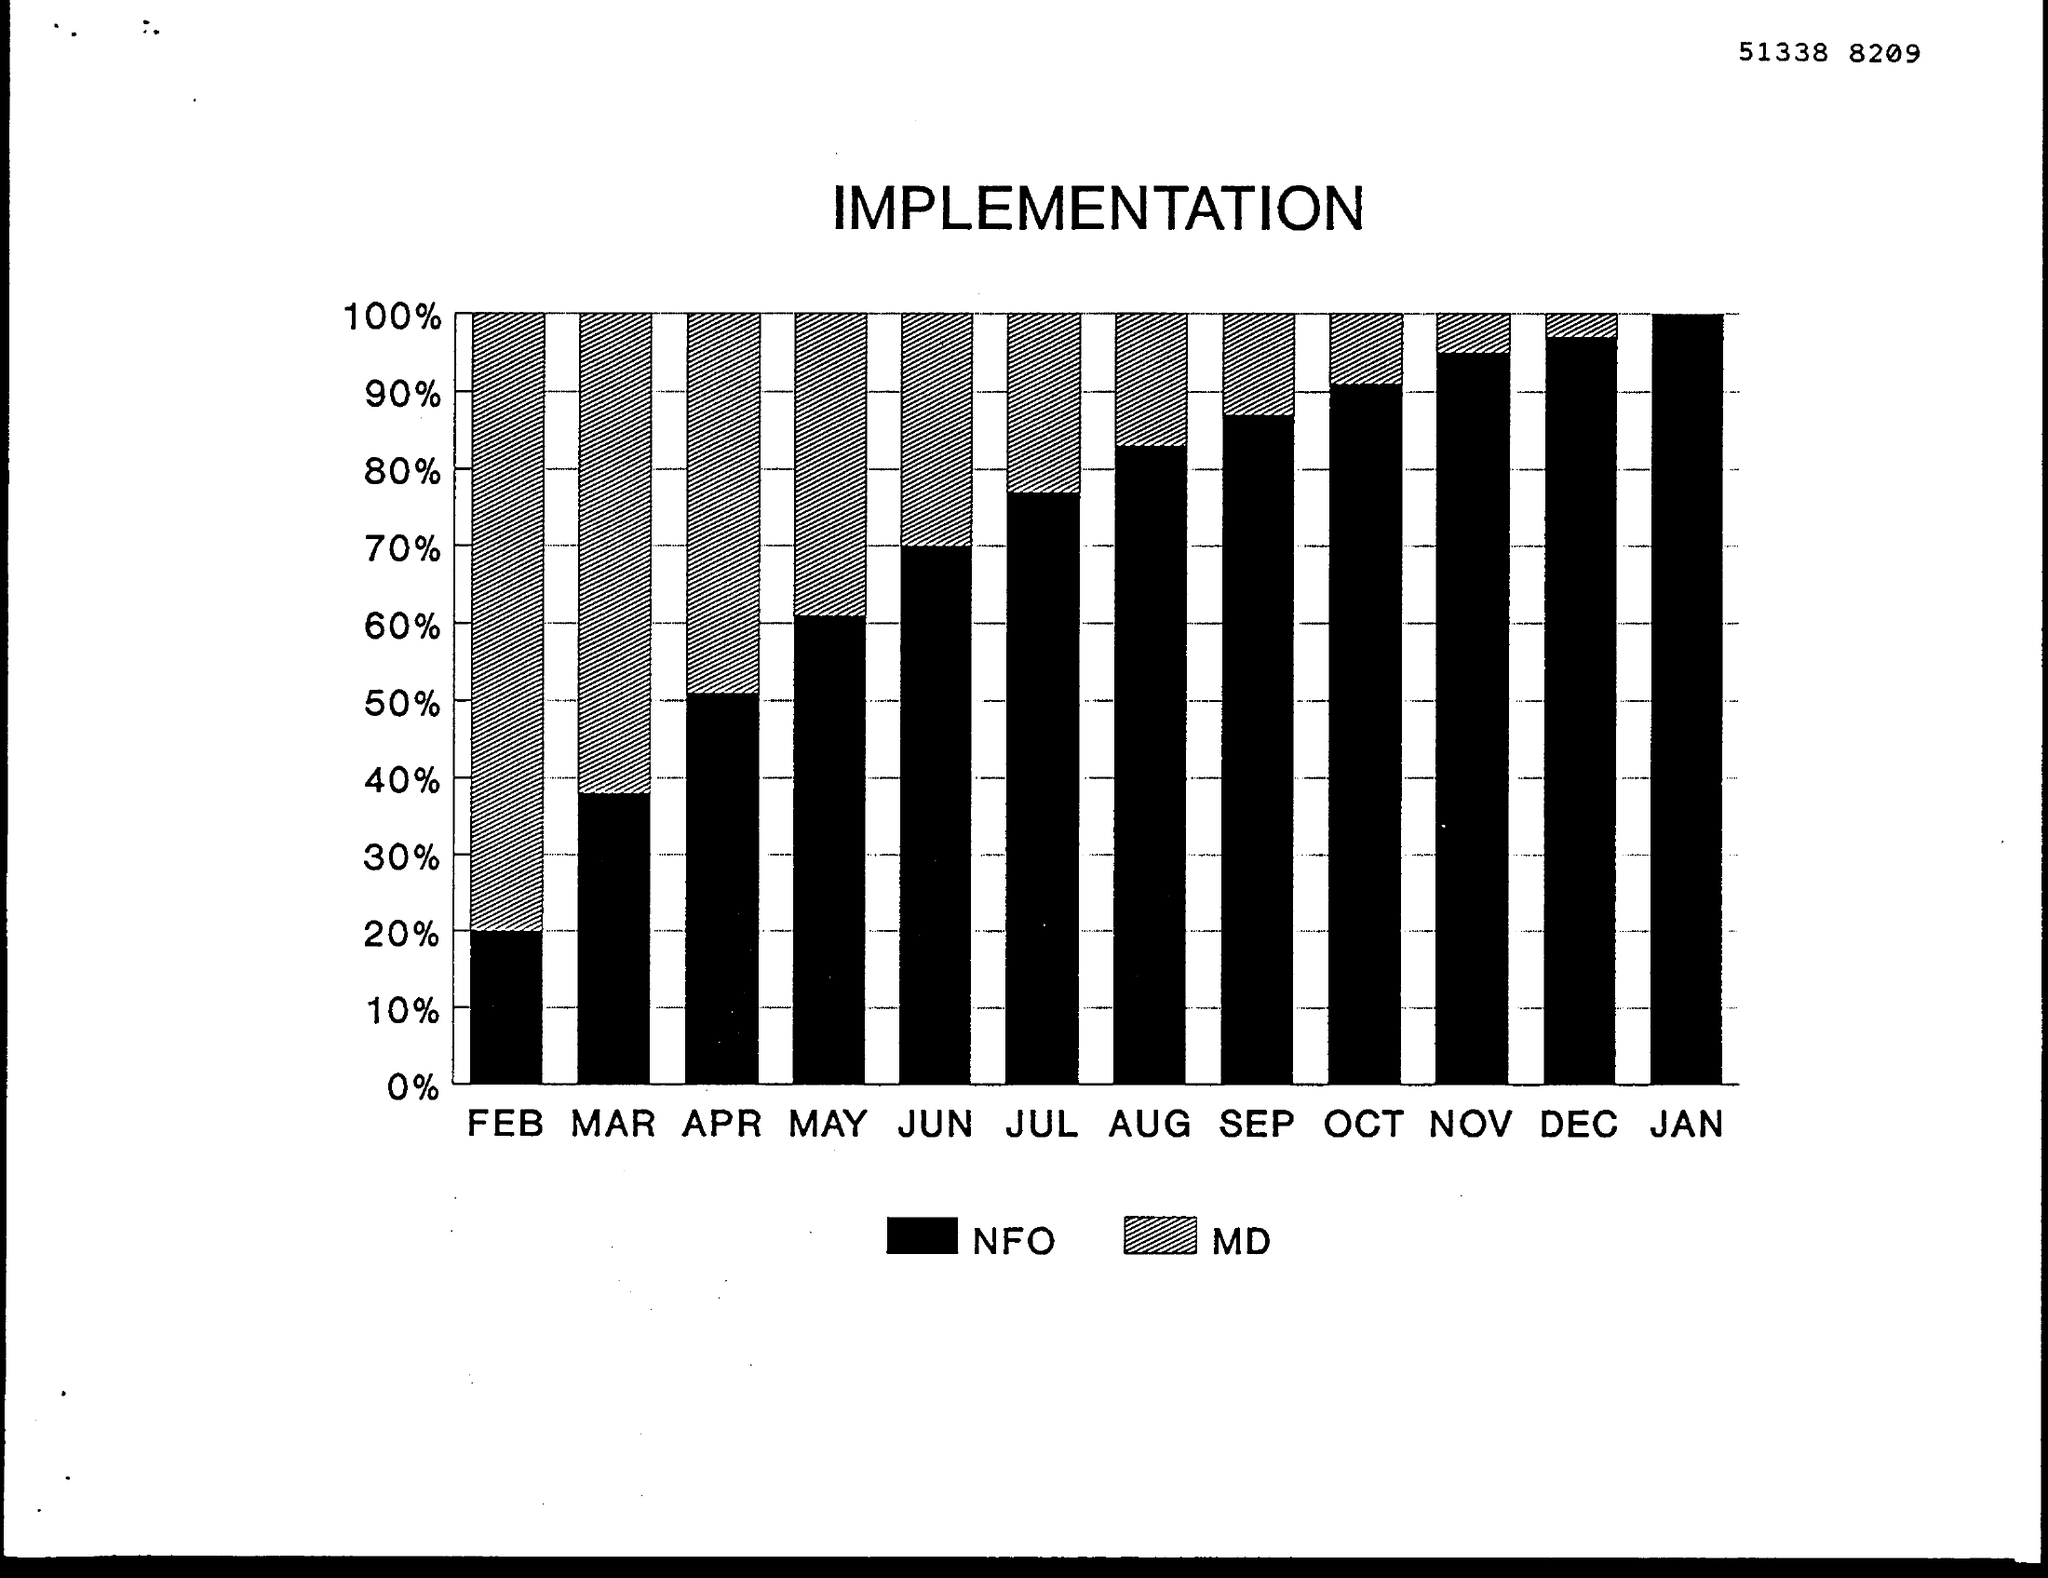What is the % of implementation of nfo in the month of oct ?
Provide a succinct answer. 90%. What is the % of implementation of md in the month of feb ?
Keep it short and to the point. 80%. What is  the % of implementation of nfo in the month of jan ?
Your answer should be compact. 100%. What is the % of implementation of nfo in the month of jun ?
Keep it short and to the point. 70%. What is the % of implementation of md in the month of apr ?
Provide a short and direct response. 50%. In which month the % of implementation of md is 30%
Your response must be concise. JUN. What is the % of implementation of nfo in the month of feb ?
Ensure brevity in your answer.  20%. 